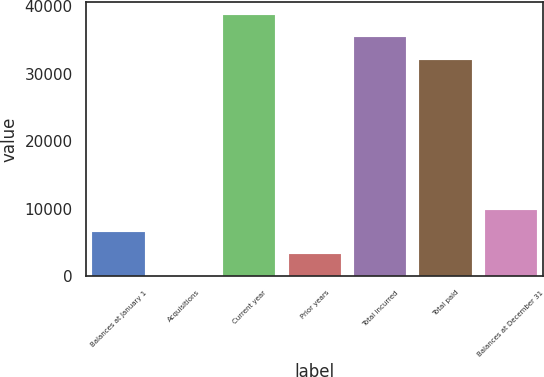<chart> <loc_0><loc_0><loc_500><loc_500><bar_chart><fcel>Balances at January 1<fcel>Acquisitions<fcel>Current year<fcel>Prior years<fcel>Total incurred<fcel>Total paid<fcel>Balances at December 31<nl><fcel>6546.2<fcel>5<fcel>38665.2<fcel>3275.6<fcel>35394.6<fcel>32124<fcel>9816.8<nl></chart> 